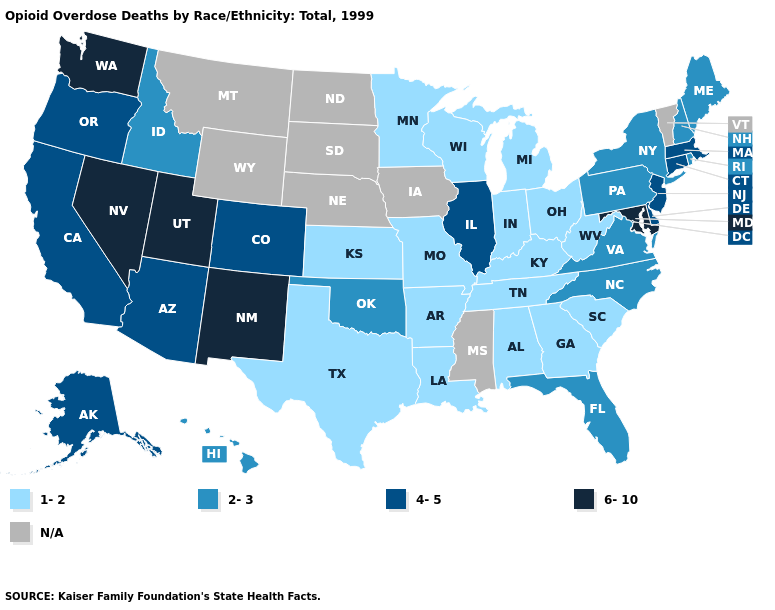What is the value of Hawaii?
Quick response, please. 2-3. Among the states that border Louisiana , which have the highest value?
Concise answer only. Arkansas, Texas. Which states hav the highest value in the South?
Quick response, please. Maryland. Does the first symbol in the legend represent the smallest category?
Concise answer only. Yes. Does Oklahoma have the lowest value in the USA?
Answer briefly. No. What is the lowest value in the USA?
Quick response, please. 1-2. How many symbols are there in the legend?
Keep it brief. 5. What is the lowest value in the West?
Write a very short answer. 2-3. Name the states that have a value in the range 4-5?
Give a very brief answer. Alaska, Arizona, California, Colorado, Connecticut, Delaware, Illinois, Massachusetts, New Jersey, Oregon. Name the states that have a value in the range 4-5?
Keep it brief. Alaska, Arizona, California, Colorado, Connecticut, Delaware, Illinois, Massachusetts, New Jersey, Oregon. What is the value of Utah?
Keep it brief. 6-10. What is the value of Georgia?
Short answer required. 1-2. Is the legend a continuous bar?
Write a very short answer. No. Name the states that have a value in the range 4-5?
Be succinct. Alaska, Arizona, California, Colorado, Connecticut, Delaware, Illinois, Massachusetts, New Jersey, Oregon. 